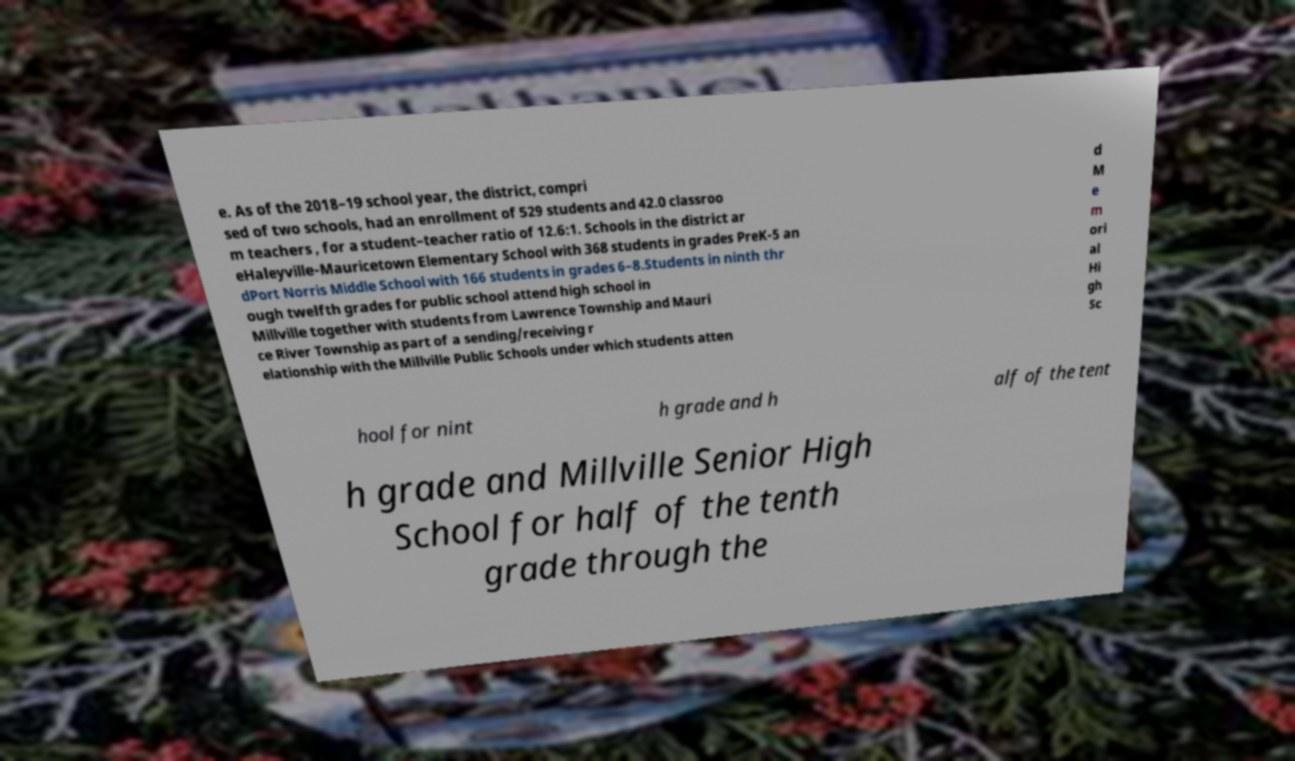I need the written content from this picture converted into text. Can you do that? e. As of the 2018–19 school year, the district, compri sed of two schools, had an enrollment of 529 students and 42.0 classroo m teachers , for a student–teacher ratio of 12.6:1. Schools in the district ar eHaleyville-Mauricetown Elementary School with 368 students in grades PreK-5 an dPort Norris Middle School with 166 students in grades 6–8.Students in ninth thr ough twelfth grades for public school attend high school in Millville together with students from Lawrence Township and Mauri ce River Township as part of a sending/receiving r elationship with the Millville Public Schools under which students atten d M e m ori al Hi gh Sc hool for nint h grade and h alf of the tent h grade and Millville Senior High School for half of the tenth grade through the 